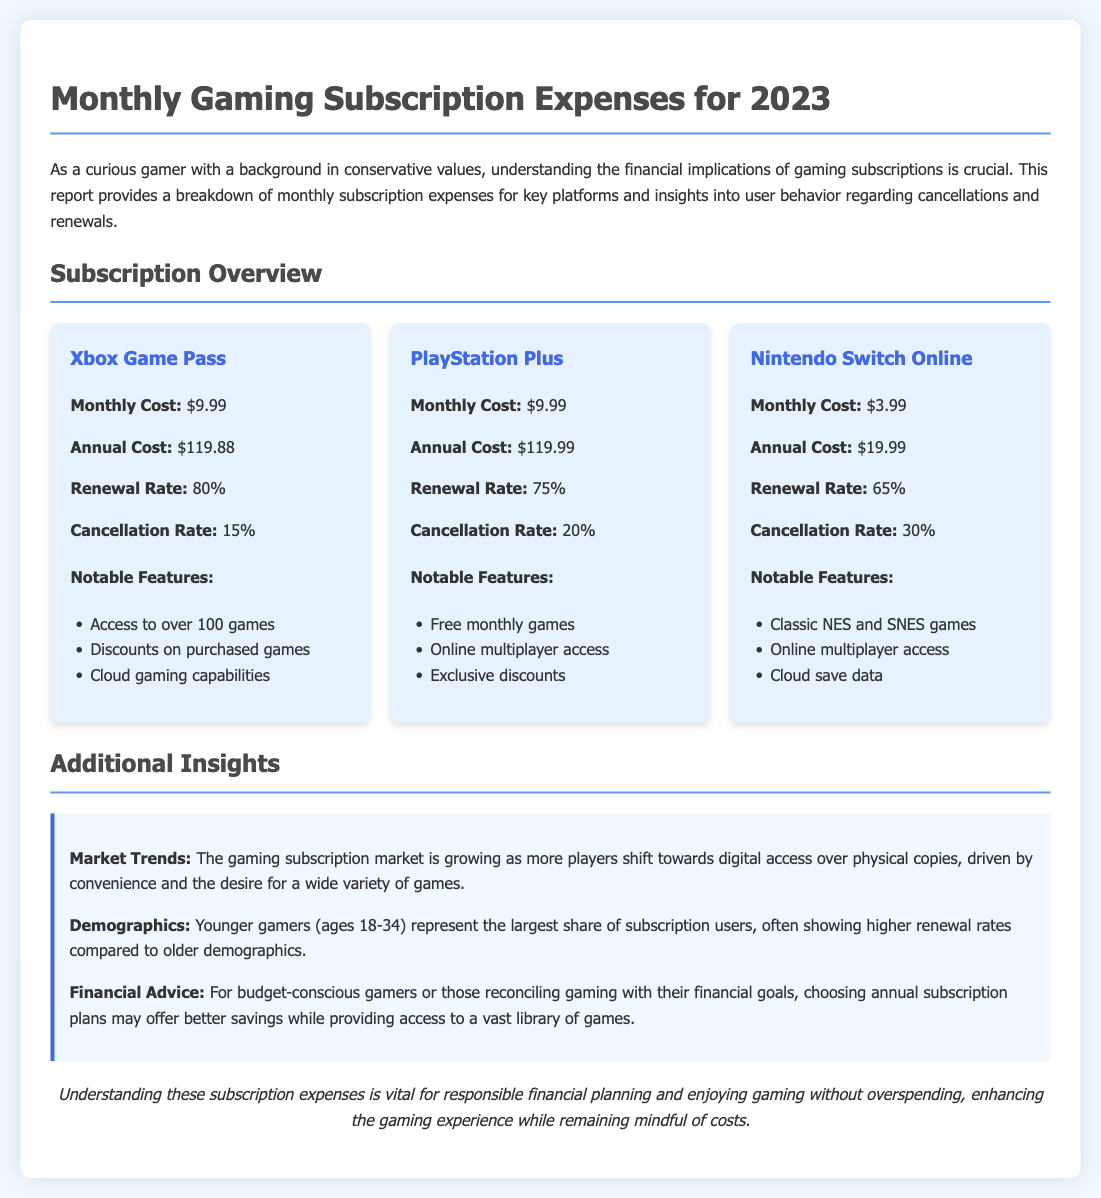what is the monthly cost of Xbox Game Pass? The monthly cost for Xbox Game Pass is stated as $9.99.
Answer: $9.99 what is the cancellation rate for PlayStation Plus? The document lists the cancellation rate for PlayStation Plus as 20%.
Answer: 20% which subscription has the highest renewal rate? Comparing the renewal rates, Xbox Game Pass has the highest at 80%.
Answer: Xbox Game Pass what is the annual cost of Nintendo Switch Online? The report specifies the annual cost for Nintendo Switch Online as $19.99.
Answer: $19.99 what notable feature is unique to Nintendo Switch Online? The notable feature unique to Nintendo Switch Online is access to classic NES and SNES games.
Answer: Classic NES and SNES games how many users represent the largest share of subscription users? The report mentions that younger gamers (ages 18-34) represent the largest share of subscription users.
Answer: Younger gamers (ages 18-34) what is the monthly cost for PlayStation Plus? The monthly cost for PlayStation Plus is stated as $9.99.
Answer: $9.99 what financial advice is given for budget-conscious gamers? The report advises that choosing annual subscription plans may offer better savings.
Answer: Annual subscription plans what trend is mentioned regarding the gaming subscription market? The document discusses a growing trend toward digital access over physical copies in the gaming subscription market.
Answer: Growing trend toward digital access 